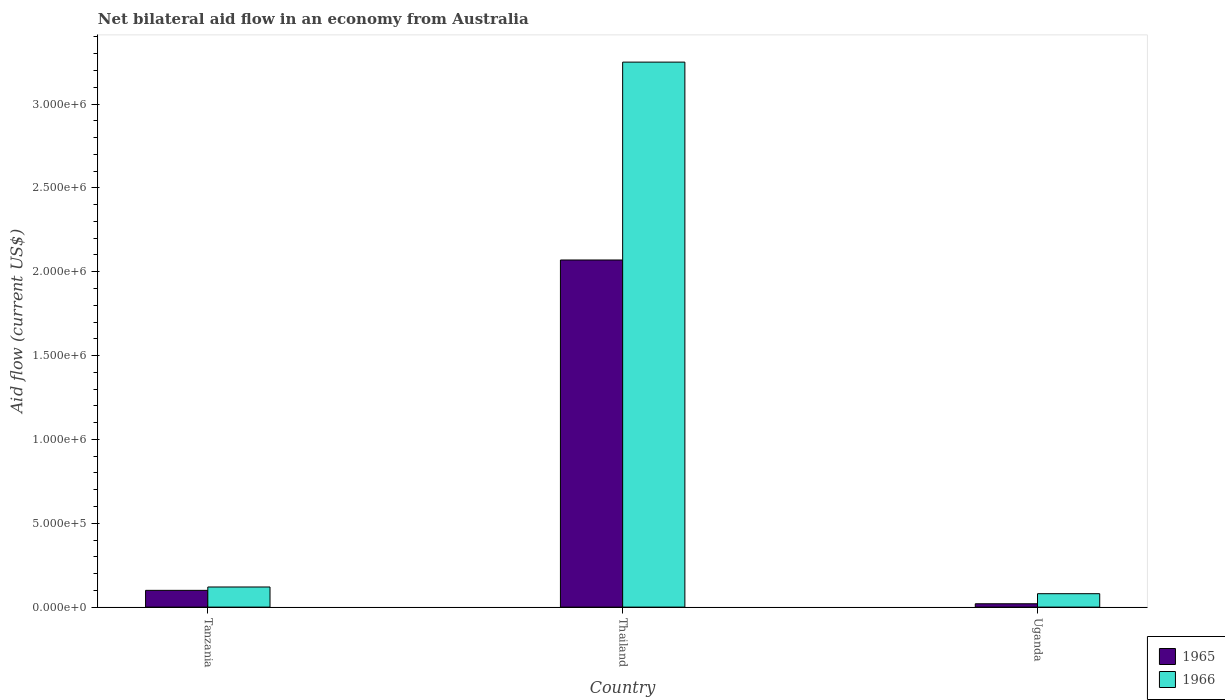How many groups of bars are there?
Your response must be concise. 3. Are the number of bars on each tick of the X-axis equal?
Ensure brevity in your answer.  Yes. How many bars are there on the 3rd tick from the left?
Ensure brevity in your answer.  2. How many bars are there on the 3rd tick from the right?
Your response must be concise. 2. What is the label of the 1st group of bars from the left?
Your response must be concise. Tanzania. In how many cases, is the number of bars for a given country not equal to the number of legend labels?
Your answer should be very brief. 0. Across all countries, what is the maximum net bilateral aid flow in 1965?
Make the answer very short. 2.07e+06. In which country was the net bilateral aid flow in 1966 maximum?
Your answer should be very brief. Thailand. In which country was the net bilateral aid flow in 1966 minimum?
Offer a very short reply. Uganda. What is the total net bilateral aid flow in 1966 in the graph?
Your response must be concise. 3.45e+06. What is the difference between the net bilateral aid flow in 1966 in Thailand and the net bilateral aid flow in 1965 in Tanzania?
Keep it short and to the point. 3.15e+06. What is the average net bilateral aid flow in 1965 per country?
Provide a short and direct response. 7.30e+05. In how many countries, is the net bilateral aid flow in 1965 greater than 2200000 US$?
Give a very brief answer. 0. What is the ratio of the net bilateral aid flow in 1966 in Tanzania to that in Thailand?
Provide a succinct answer. 0.04. Is the net bilateral aid flow in 1966 in Tanzania less than that in Thailand?
Your answer should be compact. Yes. What is the difference between the highest and the second highest net bilateral aid flow in 1966?
Make the answer very short. 3.17e+06. What is the difference between the highest and the lowest net bilateral aid flow in 1966?
Your response must be concise. 3.17e+06. What does the 2nd bar from the left in Tanzania represents?
Your answer should be very brief. 1966. What does the 1st bar from the right in Thailand represents?
Make the answer very short. 1966. How many bars are there?
Keep it short and to the point. 6. How many countries are there in the graph?
Provide a short and direct response. 3. Does the graph contain any zero values?
Offer a terse response. No. What is the title of the graph?
Offer a terse response. Net bilateral aid flow in an economy from Australia. What is the label or title of the X-axis?
Make the answer very short. Country. What is the Aid flow (current US$) in 1965 in Thailand?
Your answer should be compact. 2.07e+06. What is the Aid flow (current US$) in 1966 in Thailand?
Your response must be concise. 3.25e+06. Across all countries, what is the maximum Aid flow (current US$) of 1965?
Offer a very short reply. 2.07e+06. Across all countries, what is the maximum Aid flow (current US$) of 1966?
Provide a succinct answer. 3.25e+06. What is the total Aid flow (current US$) of 1965 in the graph?
Give a very brief answer. 2.19e+06. What is the total Aid flow (current US$) of 1966 in the graph?
Provide a succinct answer. 3.45e+06. What is the difference between the Aid flow (current US$) in 1965 in Tanzania and that in Thailand?
Your response must be concise. -1.97e+06. What is the difference between the Aid flow (current US$) of 1966 in Tanzania and that in Thailand?
Give a very brief answer. -3.13e+06. What is the difference between the Aid flow (current US$) of 1966 in Tanzania and that in Uganda?
Give a very brief answer. 4.00e+04. What is the difference between the Aid flow (current US$) of 1965 in Thailand and that in Uganda?
Your response must be concise. 2.05e+06. What is the difference between the Aid flow (current US$) in 1966 in Thailand and that in Uganda?
Provide a short and direct response. 3.17e+06. What is the difference between the Aid flow (current US$) of 1965 in Tanzania and the Aid flow (current US$) of 1966 in Thailand?
Provide a succinct answer. -3.15e+06. What is the difference between the Aid flow (current US$) in 1965 in Tanzania and the Aid flow (current US$) in 1966 in Uganda?
Your answer should be compact. 2.00e+04. What is the difference between the Aid flow (current US$) of 1965 in Thailand and the Aid flow (current US$) of 1966 in Uganda?
Keep it short and to the point. 1.99e+06. What is the average Aid flow (current US$) of 1965 per country?
Your answer should be very brief. 7.30e+05. What is the average Aid flow (current US$) in 1966 per country?
Keep it short and to the point. 1.15e+06. What is the difference between the Aid flow (current US$) of 1965 and Aid flow (current US$) of 1966 in Thailand?
Provide a short and direct response. -1.18e+06. What is the difference between the Aid flow (current US$) of 1965 and Aid flow (current US$) of 1966 in Uganda?
Provide a short and direct response. -6.00e+04. What is the ratio of the Aid flow (current US$) of 1965 in Tanzania to that in Thailand?
Your answer should be compact. 0.05. What is the ratio of the Aid flow (current US$) of 1966 in Tanzania to that in Thailand?
Your answer should be compact. 0.04. What is the ratio of the Aid flow (current US$) in 1965 in Tanzania to that in Uganda?
Ensure brevity in your answer.  5. What is the ratio of the Aid flow (current US$) of 1965 in Thailand to that in Uganda?
Offer a very short reply. 103.5. What is the ratio of the Aid flow (current US$) of 1966 in Thailand to that in Uganda?
Keep it short and to the point. 40.62. What is the difference between the highest and the second highest Aid flow (current US$) in 1965?
Ensure brevity in your answer.  1.97e+06. What is the difference between the highest and the second highest Aid flow (current US$) in 1966?
Keep it short and to the point. 3.13e+06. What is the difference between the highest and the lowest Aid flow (current US$) of 1965?
Keep it short and to the point. 2.05e+06. What is the difference between the highest and the lowest Aid flow (current US$) in 1966?
Provide a succinct answer. 3.17e+06. 